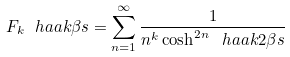Convert formula to latex. <formula><loc_0><loc_0><loc_500><loc_500>F _ { k } \ h a a k { \beta s } = \sum _ { n = 1 } ^ { \infty } \frac { 1 } { n ^ { k } \cosh ^ { 2 n } \ h a a k { 2 \beta s } }</formula> 